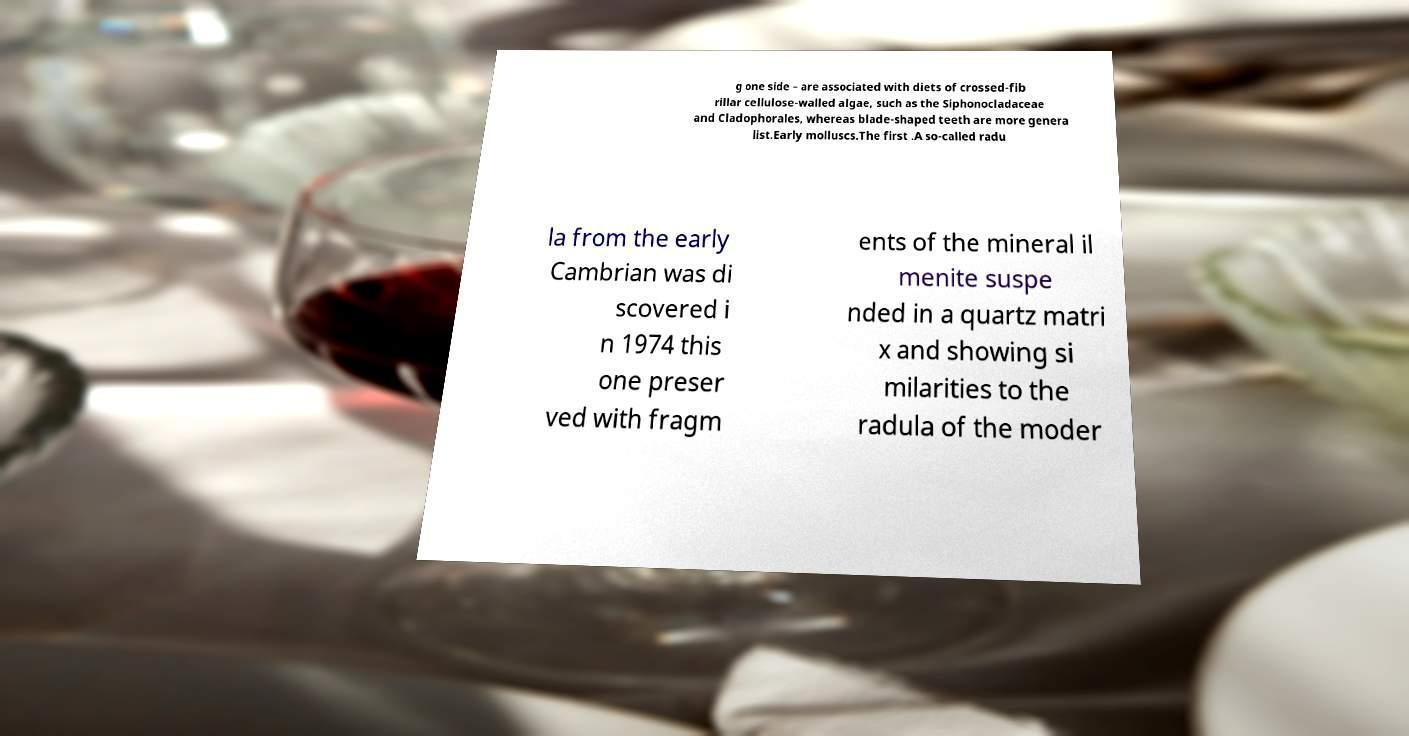What messages or text are displayed in this image? I need them in a readable, typed format. g one side – are associated with diets of crossed-fib rillar cellulose-walled algae, such as the Siphonocladaceae and Cladophorales, whereas blade-shaped teeth are more genera list.Early molluscs.The first .A so-called radu la from the early Cambrian was di scovered i n 1974 this one preser ved with fragm ents of the mineral il menite suspe nded in a quartz matri x and showing si milarities to the radula of the moder 